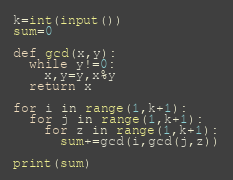Convert code to text. <code><loc_0><loc_0><loc_500><loc_500><_Python_>k=int(input())
sum=0

def gcd(x,y):
  while y!=0:
    x,y=y,x%y
  return x
    
for i in range(1,k+1):
  for j in range(1,k+1):
    for z in range(1,k+1):
      sum+=gcd(i,gcd(j,z))
      
print(sum)</code> 